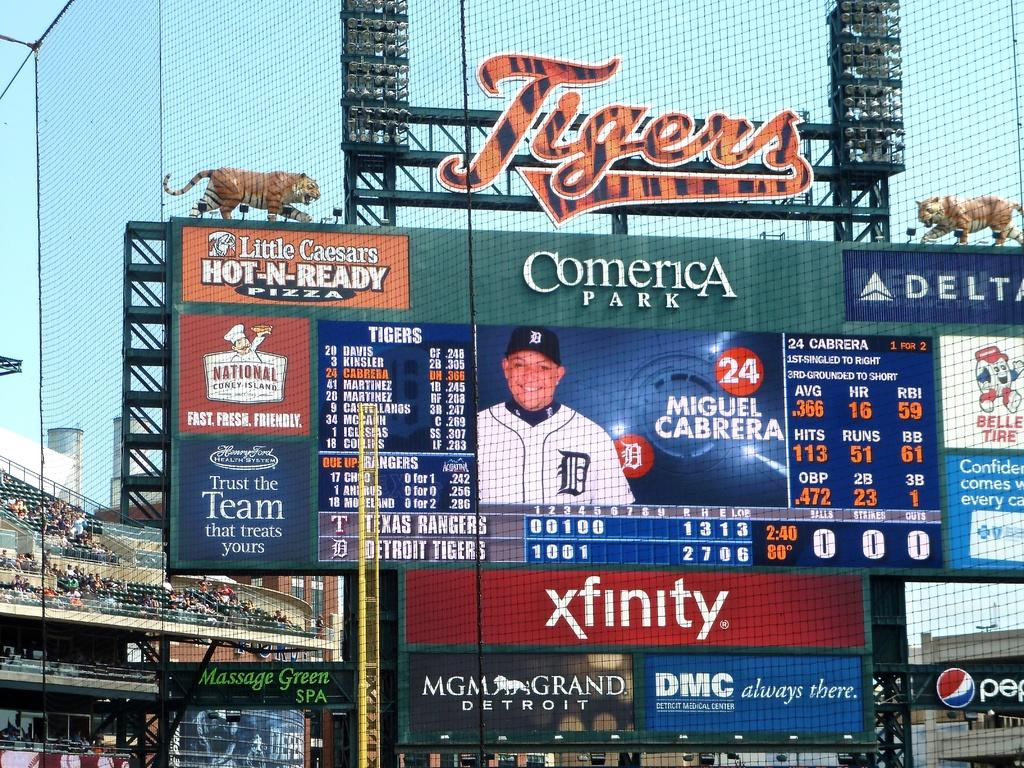<image>
Share a concise interpretation of the image provided. a sign that says comerica at the top of it 